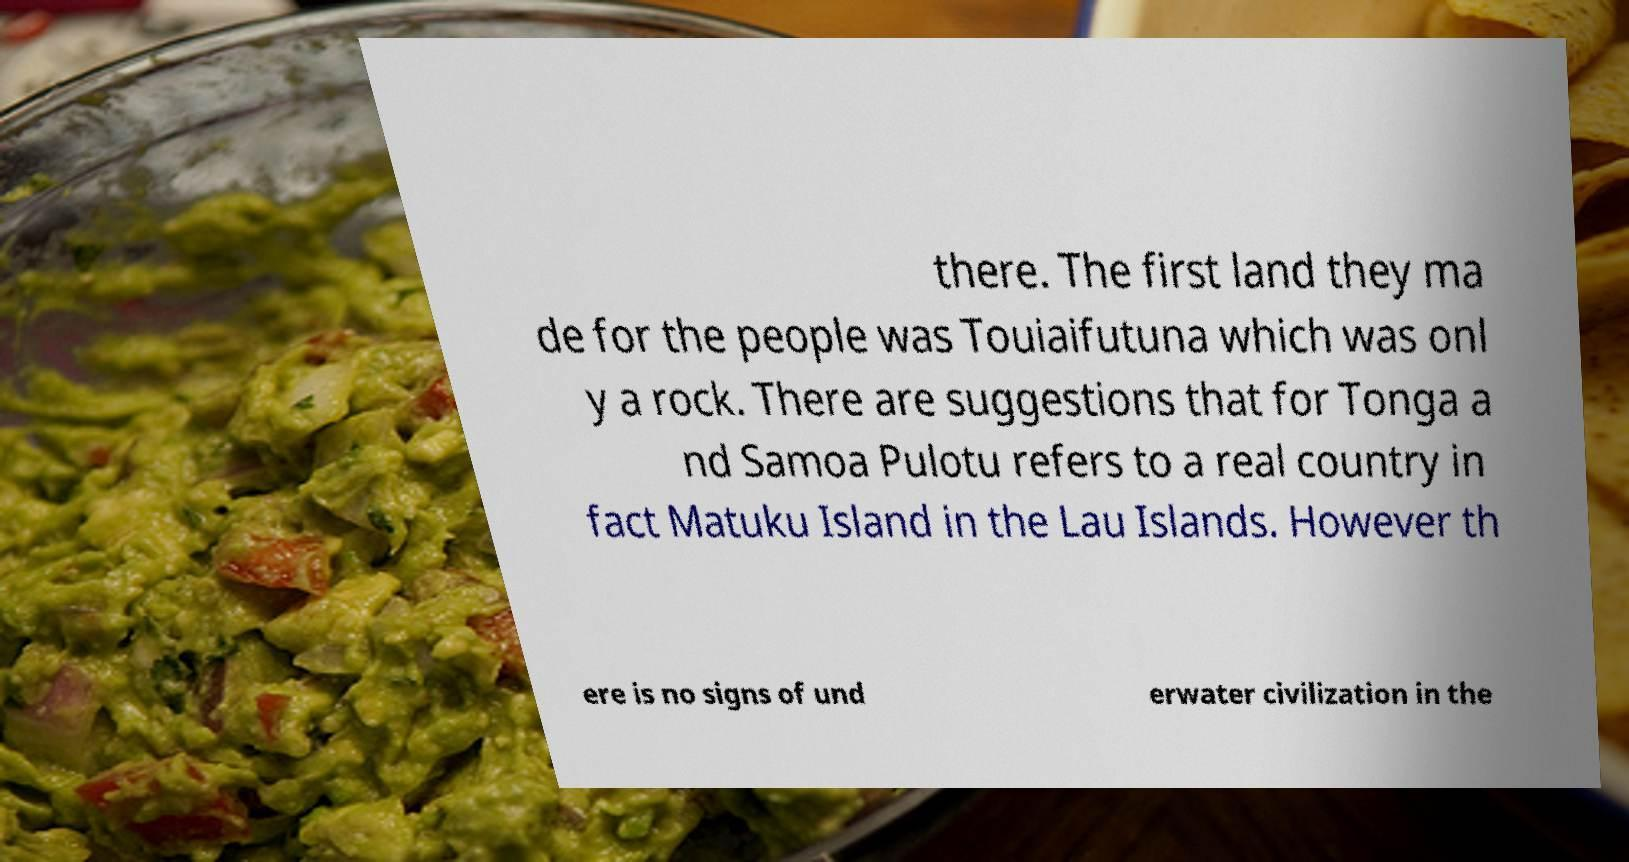Please read and relay the text visible in this image. What does it say? there. The first land they ma de for the people was Touiaifutuna which was onl y a rock. There are suggestions that for Tonga a nd Samoa Pulotu refers to a real country in fact Matuku Island in the Lau Islands. However th ere is no signs of und erwater civilization in the 